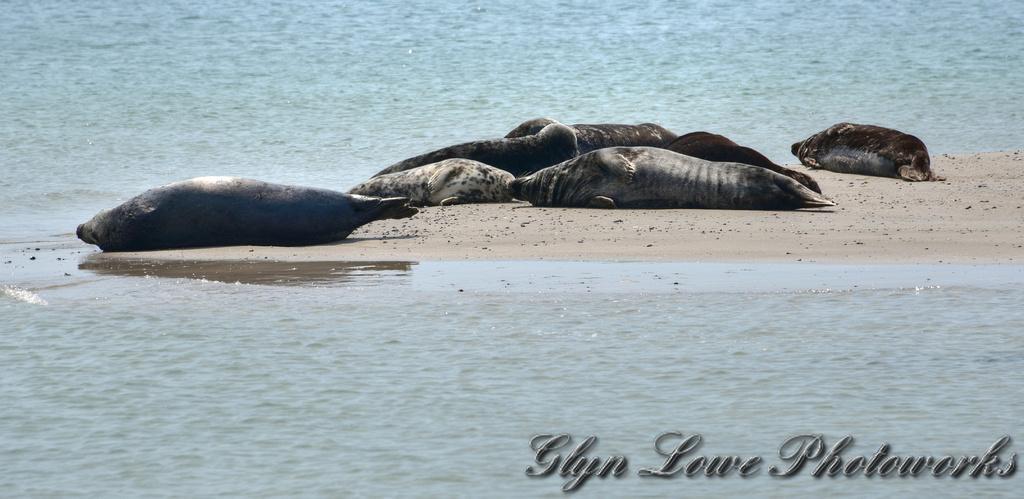Can you describe this image briefly? There are seals lying on the sand. There is water. On the right corner there is a watermark. 